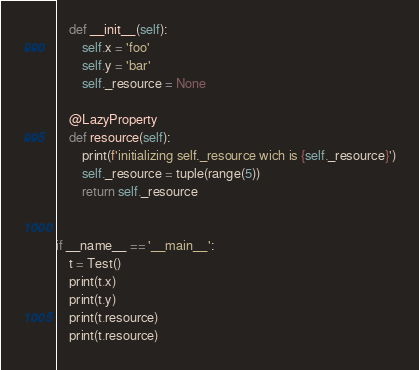Convert code to text. <code><loc_0><loc_0><loc_500><loc_500><_Python_>    def __init__(self):
        self.x = 'foo'
        self.y = 'bar'
        self._resource = None

    @LazyProperty
    def resource(self):
        print(f'initializing self._resource wich is {self._resource}')
        self._resource = tuple(range(5))
        return self._resource


if __name__ == '__main__':
    t = Test()
    print(t.x)
    print(t.y)
    print(t.resource)
    print(t.resource)
</code> 